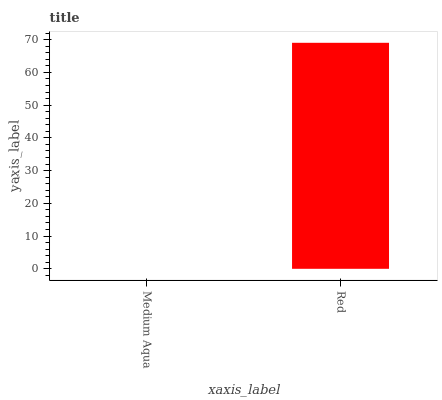Is Medium Aqua the minimum?
Answer yes or no. Yes. Is Red the maximum?
Answer yes or no. Yes. Is Red the minimum?
Answer yes or no. No. Is Red greater than Medium Aqua?
Answer yes or no. Yes. Is Medium Aqua less than Red?
Answer yes or no. Yes. Is Medium Aqua greater than Red?
Answer yes or no. No. Is Red less than Medium Aqua?
Answer yes or no. No. Is Red the high median?
Answer yes or no. Yes. Is Medium Aqua the low median?
Answer yes or no. Yes. Is Medium Aqua the high median?
Answer yes or no. No. Is Red the low median?
Answer yes or no. No. 